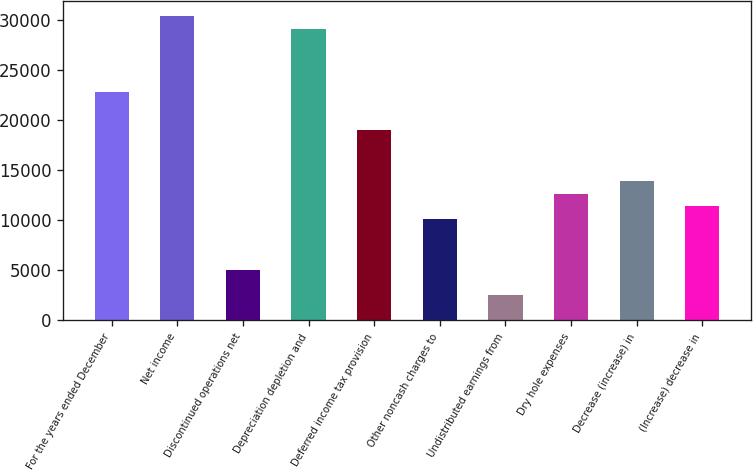<chart> <loc_0><loc_0><loc_500><loc_500><bar_chart><fcel>For the years ended December<fcel>Net income<fcel>Discontinued operations net<fcel>Depreciation depletion and<fcel>Deferred income tax provision<fcel>Other noncash charges to<fcel>Undistributed earnings from<fcel>Dry hole expenses<fcel>Decrease (increase) in<fcel>(Increase) decrease in<nl><fcel>22778.2<fcel>30370.6<fcel>5062.6<fcel>29105.2<fcel>18982<fcel>10124.2<fcel>2531.8<fcel>12655<fcel>13920.4<fcel>11389.6<nl></chart> 